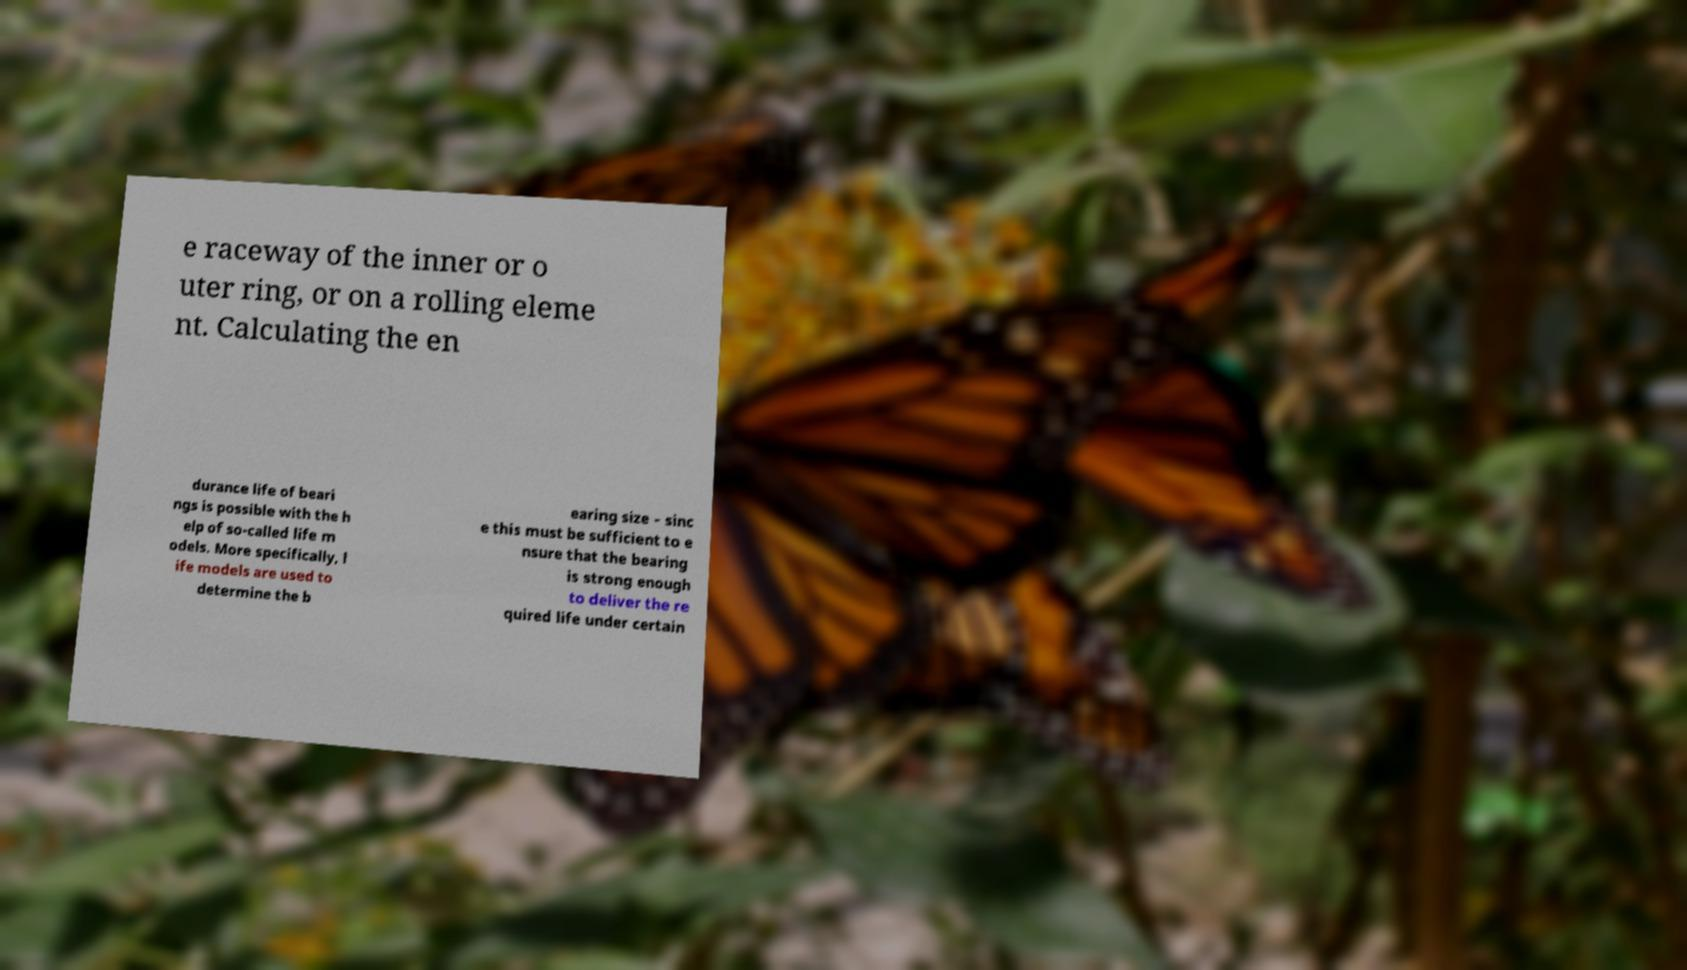Could you extract and type out the text from this image? e raceway of the inner or o uter ring, or on a rolling eleme nt. Calculating the en durance life of beari ngs is possible with the h elp of so-called life m odels. More specifically, l ife models are used to determine the b earing size – sinc e this must be sufficient to e nsure that the bearing is strong enough to deliver the re quired life under certain 